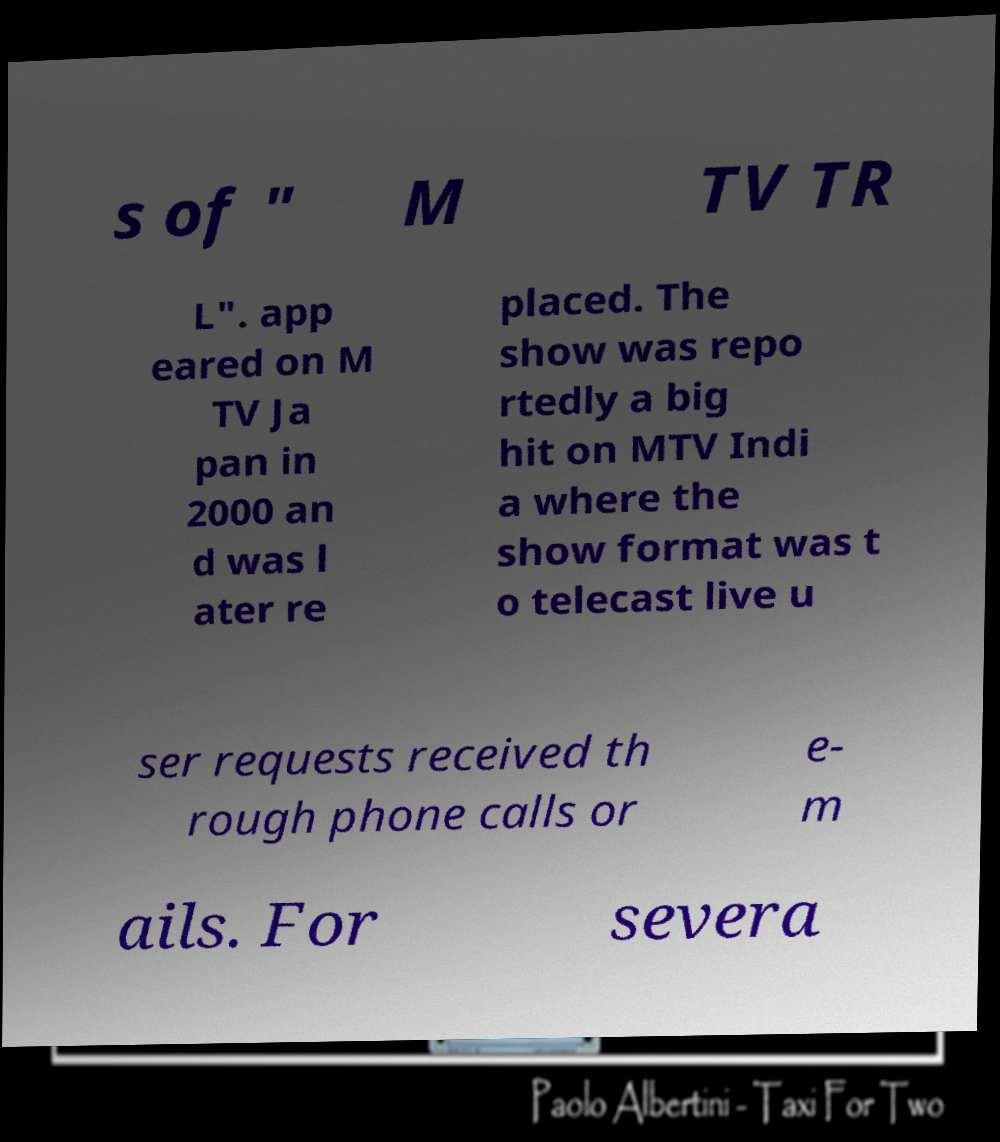Can you read and provide the text displayed in the image?This photo seems to have some interesting text. Can you extract and type it out for me? s of " M TV TR L". app eared on M TV Ja pan in 2000 an d was l ater re placed. The show was repo rtedly a big hit on MTV Indi a where the show format was t o telecast live u ser requests received th rough phone calls or e- m ails. For severa 